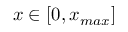Convert formula to latex. <formula><loc_0><loc_0><loc_500><loc_500>x \in [ 0 , x _ { \max } ]</formula> 